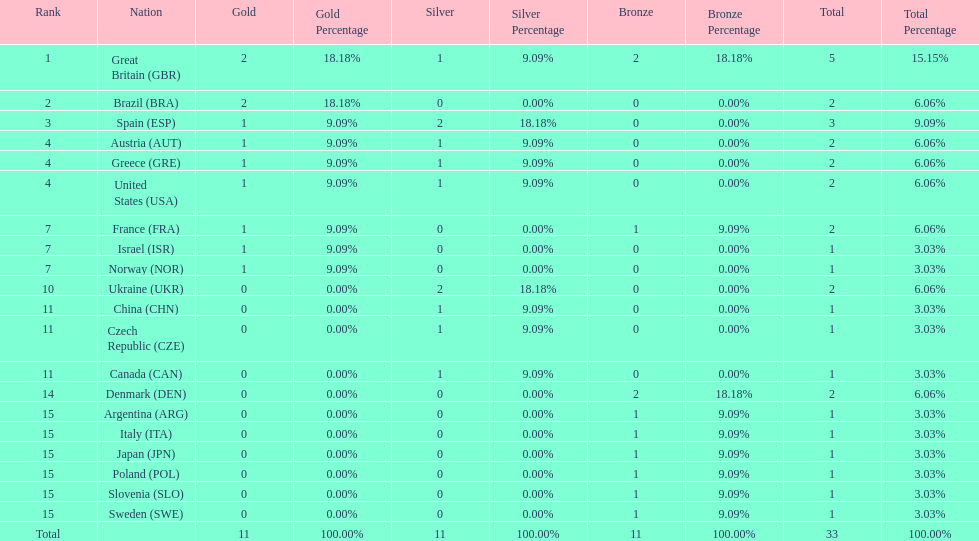What was the total number of medals won by united states? 2. 